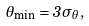Convert formula to latex. <formula><loc_0><loc_0><loc_500><loc_500>\theta _ { \min } = 3 \sigma _ { \theta } ,</formula> 